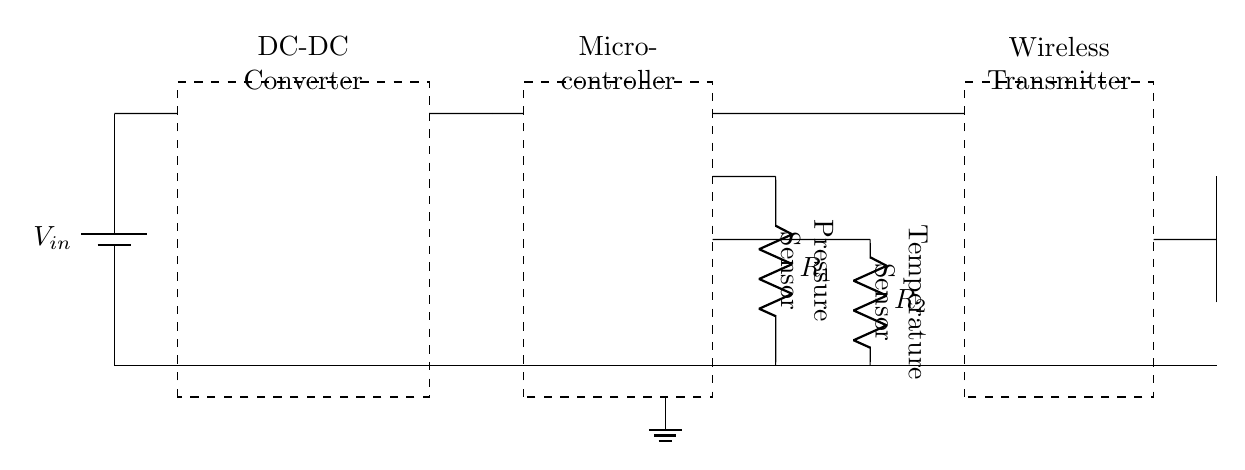What components are present in the circuit? The circuit includes a battery, DC-DC converter, microcontroller, pressure sensor, temperature sensor, wireless transmitter, and an antenna. These are the identifiable blocks in the diagram.
Answer: battery, DC-DC converter, microcontroller, pressure sensor, temperature sensor, wireless transmitter, antenna What is the purpose of the DC-DC converter? The DC-DC converter is used to adjust the voltage level supplied to the components according to their requirements. It steps up or steps down the input voltage to deliver the appropriate voltage for the microcontroller and other devices.
Answer: voltage adjustment How many sensors are in the circuit? There are two sensors present in the circuit: a pressure sensor and a temperature sensor. Each sensor is associated with a resistor.
Answer: two What does the wireless transmitter do? The wireless transmitter transmits data collected from the sensors wirelessly. It serves the function of sending information to an external device or system for monitoring or analysis.
Answer: data transmission How is the ground connected in the circuit? The ground is connected through the lower terminals of the components, allowing for a common reference point for the circuit. The ground connection is shown at the bottom of the diagram where it connects multiple components.
Answer: common reference What type of application does this circuit diagram represent? This circuit diagram represents an application for implantable medical devices. It integrates sensor data collection, processing, and wireless communication, which are typical in such devices.
Answer: implantable medical devices 